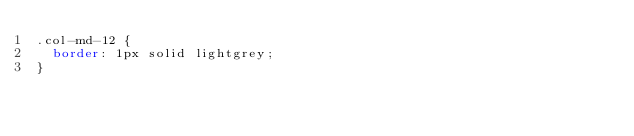<code> <loc_0><loc_0><loc_500><loc_500><_CSS_>.col-md-12 {
  border: 1px solid lightgrey;
}
</code> 